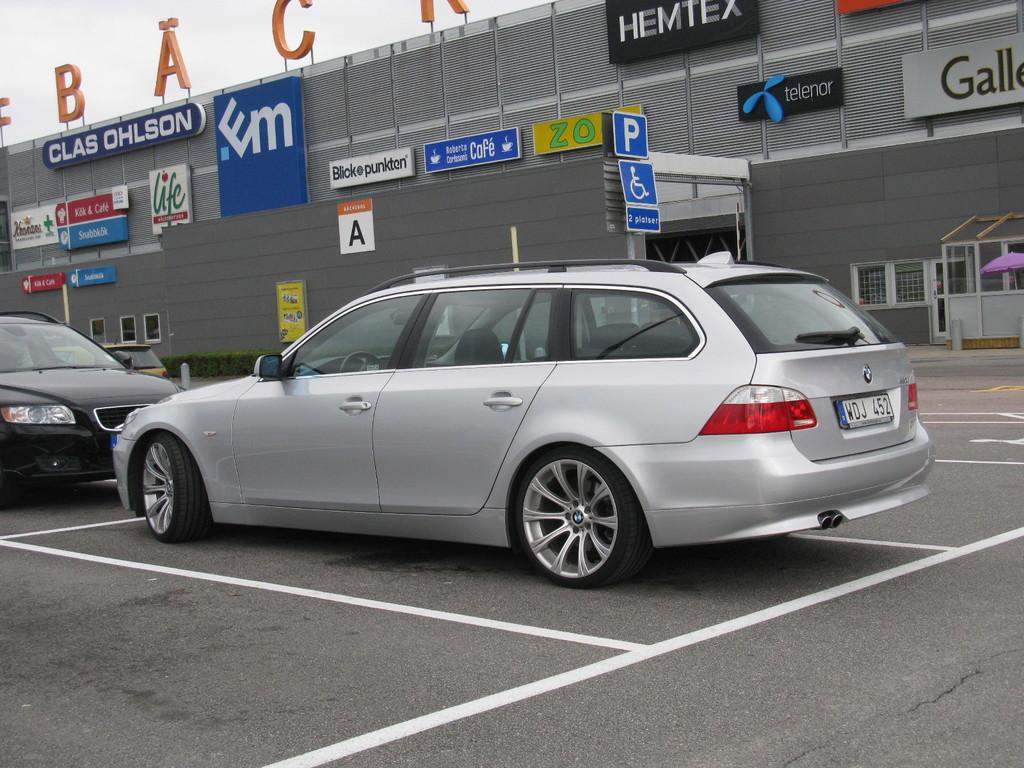Provide a one-sentence caption for the provided image. A few cars outside a building with a sign on it that says Clas Ohlson. 